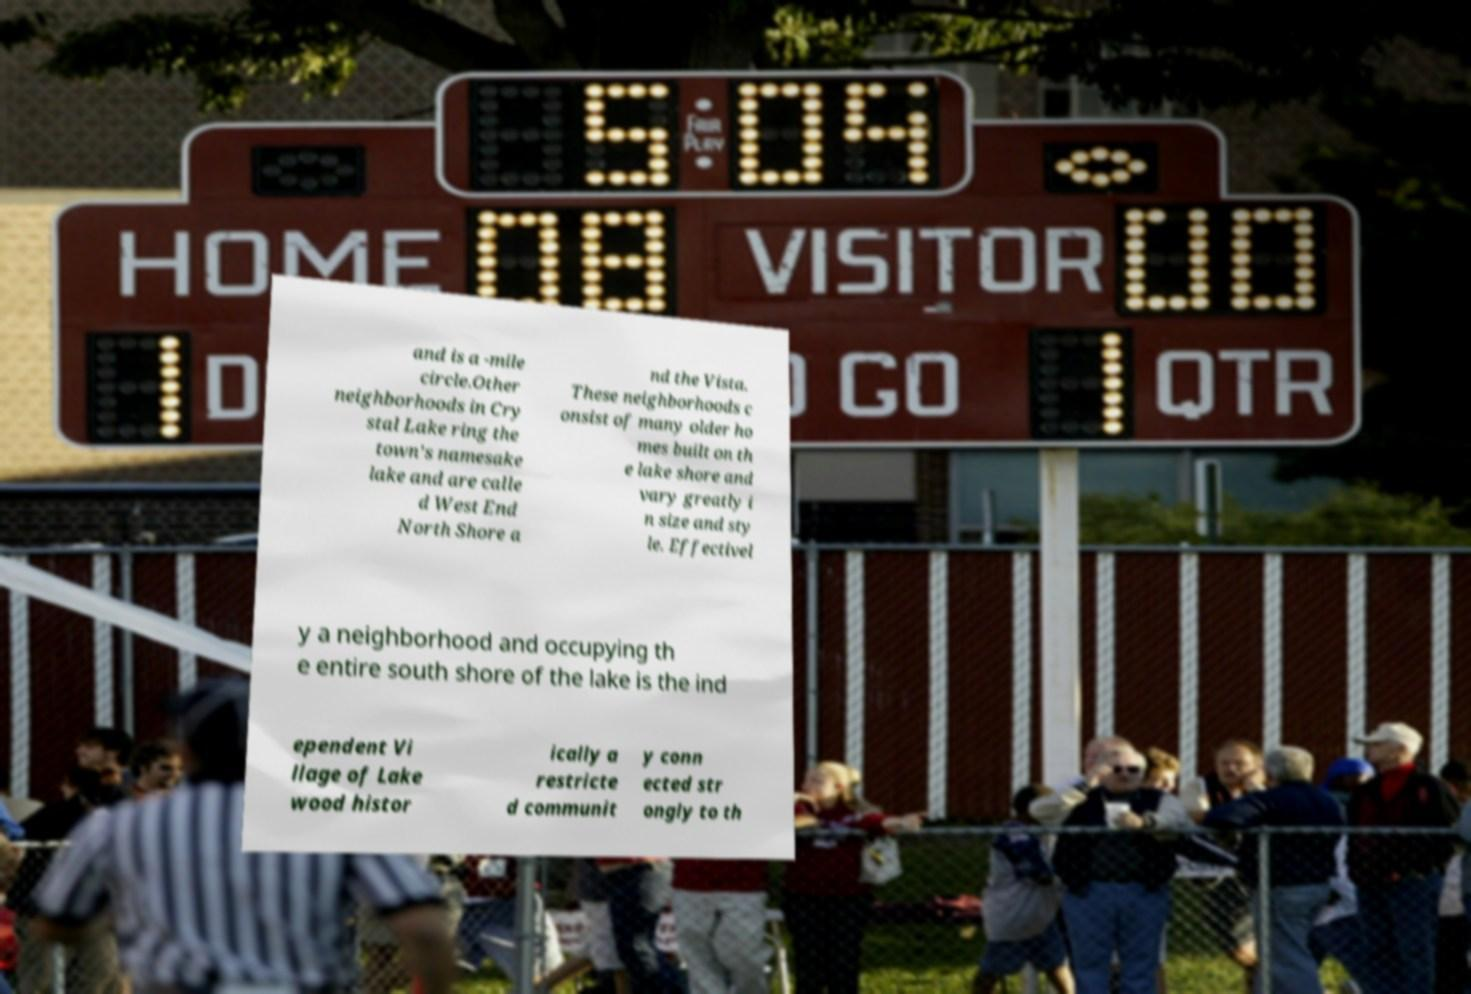Please identify and transcribe the text found in this image. and is a -mile circle.Other neighborhoods in Cry stal Lake ring the town's namesake lake and are calle d West End North Shore a nd the Vista. These neighborhoods c onsist of many older ho mes built on th e lake shore and vary greatly i n size and sty le. Effectivel y a neighborhood and occupying th e entire south shore of the lake is the ind ependent Vi llage of Lake wood histor ically a restricte d communit y conn ected str ongly to th 